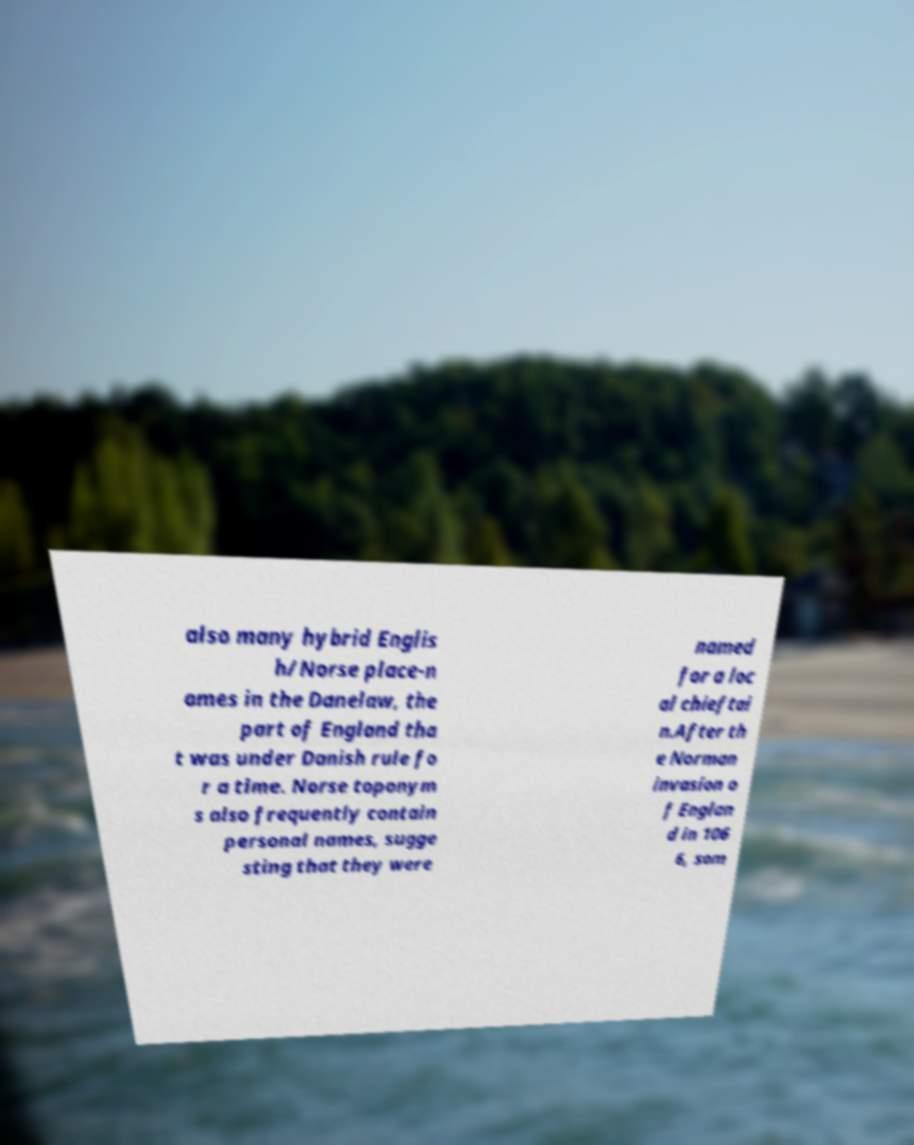Could you assist in decoding the text presented in this image and type it out clearly? also many hybrid Englis h/Norse place-n ames in the Danelaw, the part of England tha t was under Danish rule fo r a time. Norse toponym s also frequently contain personal names, sugge sting that they were named for a loc al chieftai n.After th e Norman invasion o f Englan d in 106 6, som 